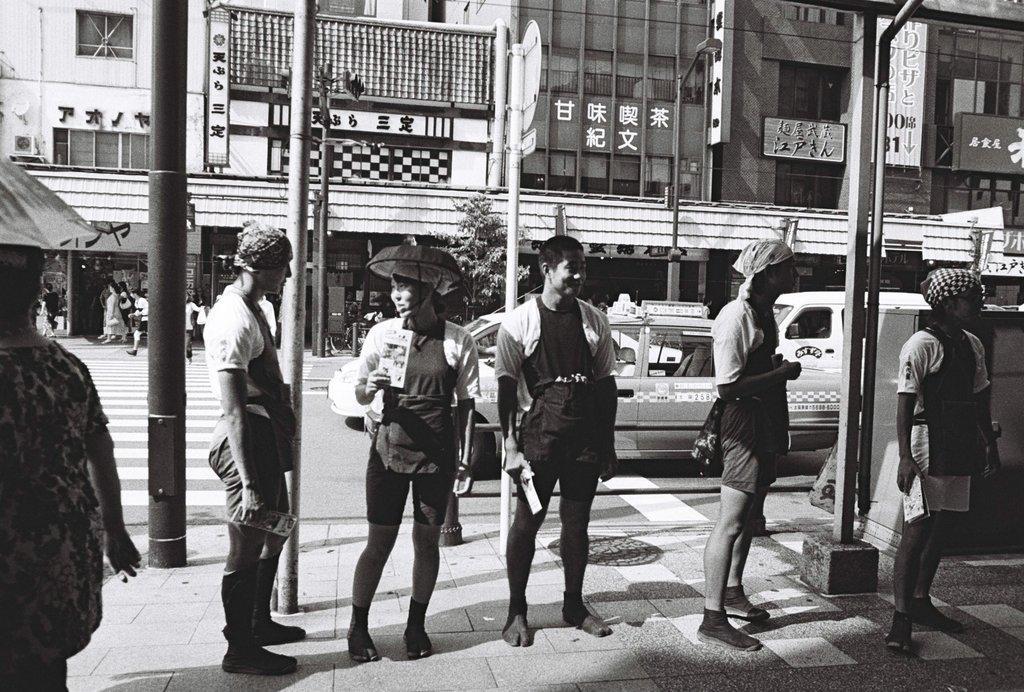Please provide a concise description of this image. In the image in the center, we can see a few people are standing and they are holding some objects. In the background, we can see buildings, banners, poles, sign boards, vehicles, few people are walking etc. 